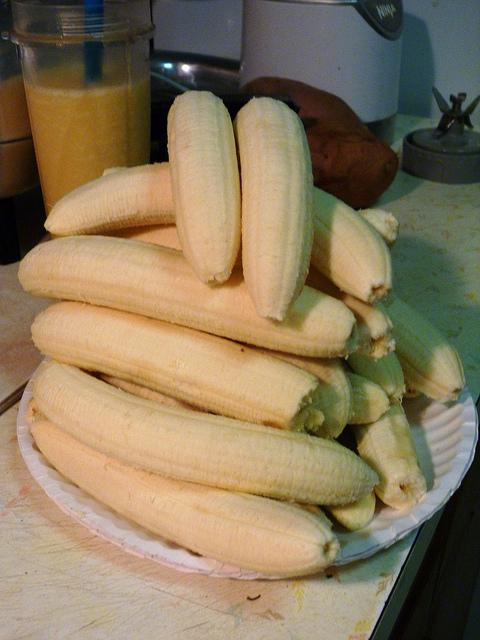What happened to these bananas? Please explain your reasoning. peeled. The other options don't match. they're still whole and not fried or baked. 